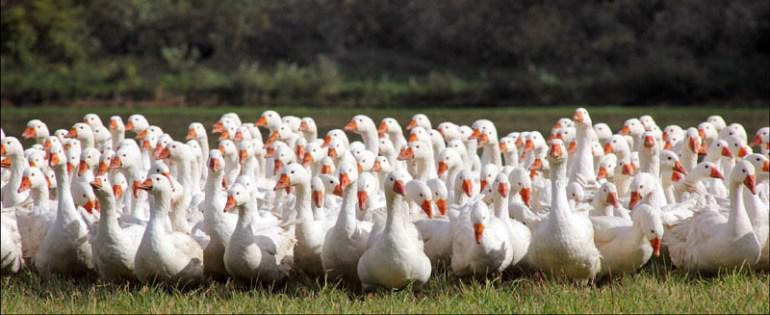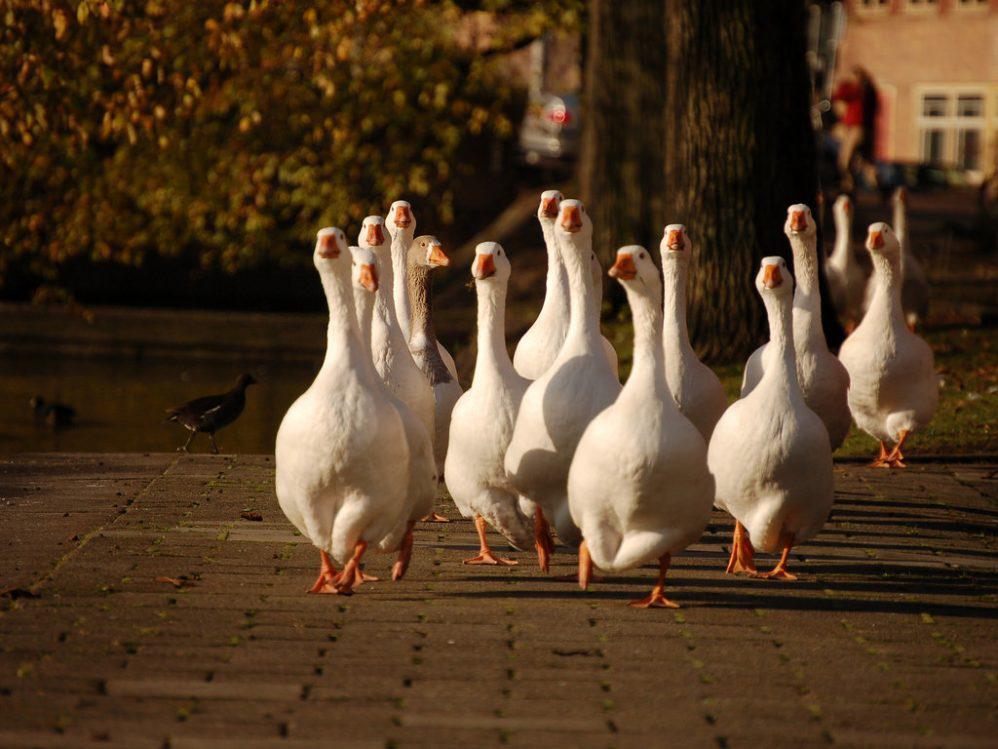The first image is the image on the left, the second image is the image on the right. Evaluate the accuracy of this statement regarding the images: "There is exactly one animal in the image on the left.". Is it true? Answer yes or no. No. The first image is the image on the left, the second image is the image on the right. Evaluate the accuracy of this statement regarding the images: "No image contains fewer than four white fowl.". Is it true? Answer yes or no. Yes. 